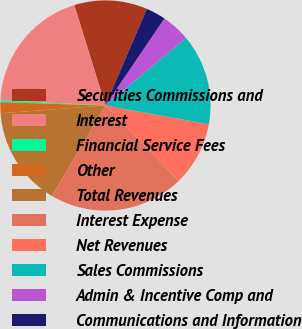Convert chart. <chart><loc_0><loc_0><loc_500><loc_500><pie_chart><fcel>Securities Commissions and<fcel>Interest<fcel>Financial Service Fees<fcel>Other<fcel>Total Revenues<fcel>Interest Expense<fcel>Net Revenues<fcel>Sales Commissions<fcel>Admin & Incentive Comp and<fcel>Communications and Information<nl><fcel>11.23%<fcel>19.41%<fcel>0.31%<fcel>1.68%<fcel>15.32%<fcel>20.78%<fcel>9.86%<fcel>13.96%<fcel>4.41%<fcel>3.04%<nl></chart> 